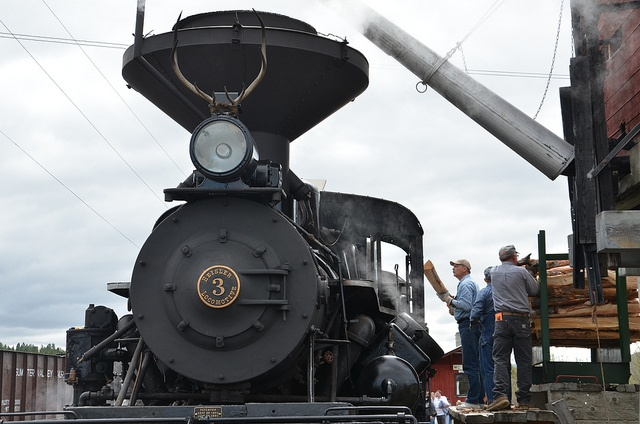Describe the objects in this image and their specific colors. I can see train in white, black, gray, and darkgray tones, people in white, black, gray, and darkgray tones, people in white, black, and gray tones, people in white, black, navy, gray, and darkblue tones, and people in white, lavender, black, gray, and darkgray tones in this image. 